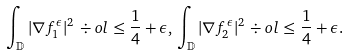Convert formula to latex. <formula><loc_0><loc_0><loc_500><loc_500>\int _ { \mathbb { D } } | \nabla f _ { 1 } ^ { \epsilon } | ^ { 2 } \, \div o l \leq \frac { 1 } { 4 } + \epsilon , \, \int _ { \mathbb { D } } | \nabla f _ { 2 } ^ { \epsilon } | ^ { 2 } \, \div o l \leq \frac { 1 } { 4 } + \epsilon .</formula> 